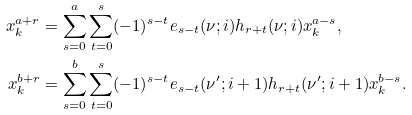Convert formula to latex. <formula><loc_0><loc_0><loc_500><loc_500>x _ { k } ^ { a + r } & = \sum _ { s = 0 } ^ { a } \sum _ { t = 0 } ^ { s } ( - 1 ) ^ { s - t } e _ { s - t } ( \nu ; i ) h _ { r + t } ( \nu ; i ) x _ { k } ^ { a - s } , \\ x _ { k } ^ { b + r } & = \sum _ { s = 0 } ^ { b } \sum _ { t = 0 } ^ { s } ( - 1 ) ^ { s - t } e _ { s - t } ( \nu ^ { \prime } ; i + 1 ) h _ { r + t } ( \nu ^ { \prime } ; i + 1 ) x _ { k } ^ { b - s } .</formula> 